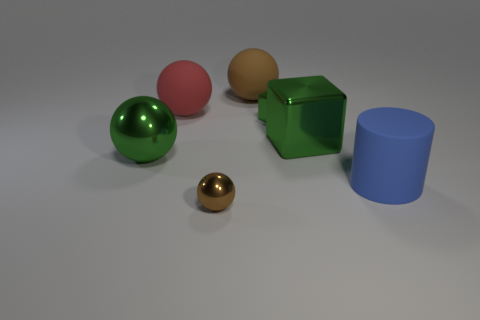Can you describe the shapes and colors of the objects seen in this image? Certainly! There are five objects of different shapes and colors: a green sphere, a pink sphere, a brown, smaller sphere which appears to be made of metal, a green cube, and a blue cylinder. 